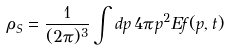<formula> <loc_0><loc_0><loc_500><loc_500>\rho _ { S } = \frac { 1 } { ( 2 \pi ) ^ { 3 } } \int d p \, 4 \pi p ^ { 2 } E f ( p , t )</formula> 